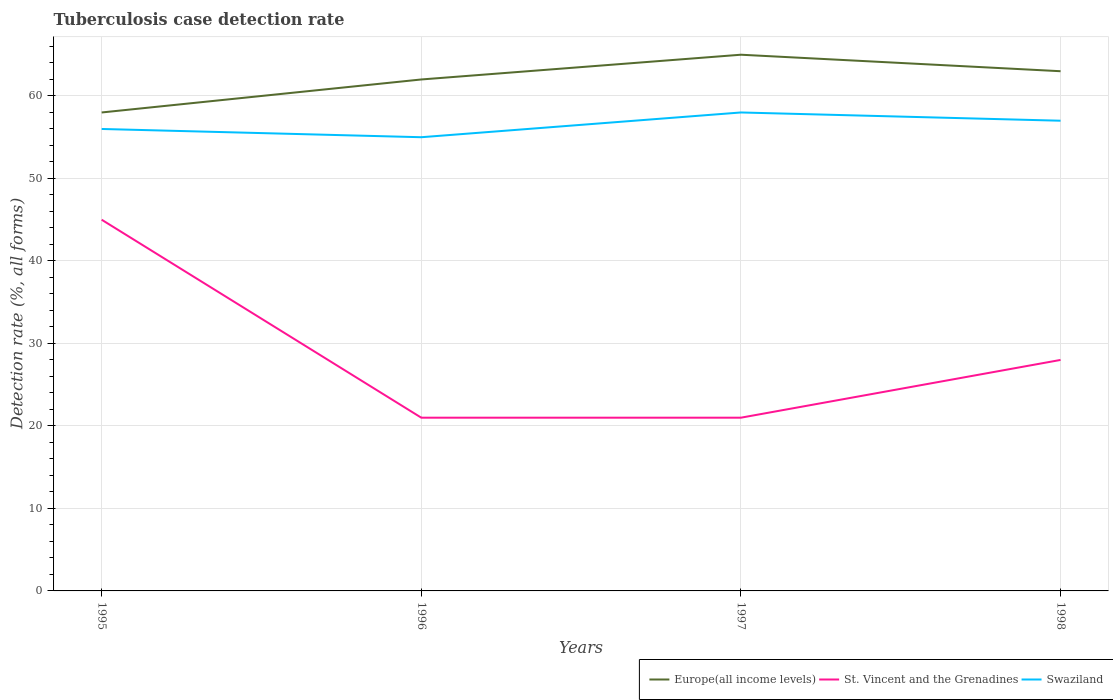Across all years, what is the maximum tuberculosis case detection rate in in St. Vincent and the Grenadines?
Provide a succinct answer. 21. What is the total tuberculosis case detection rate in in Europe(all income levels) in the graph?
Give a very brief answer. -7. What is the difference between the highest and the second highest tuberculosis case detection rate in in Europe(all income levels)?
Provide a short and direct response. 7. What is the difference between the highest and the lowest tuberculosis case detection rate in in Swaziland?
Give a very brief answer. 2. What is the difference between two consecutive major ticks on the Y-axis?
Ensure brevity in your answer.  10. Are the values on the major ticks of Y-axis written in scientific E-notation?
Ensure brevity in your answer.  No. What is the title of the graph?
Ensure brevity in your answer.  Tuberculosis case detection rate. What is the label or title of the Y-axis?
Give a very brief answer. Detection rate (%, all forms). What is the Detection rate (%, all forms) in Europe(all income levels) in 1995?
Offer a very short reply. 58. What is the Detection rate (%, all forms) in Swaziland in 1995?
Your response must be concise. 56. What is the Detection rate (%, all forms) in Europe(all income levels) in 1996?
Offer a terse response. 62. What is the Detection rate (%, all forms) in Swaziland in 1996?
Your response must be concise. 55. What is the Detection rate (%, all forms) in St. Vincent and the Grenadines in 1997?
Provide a short and direct response. 21. What is the Detection rate (%, all forms) of Europe(all income levels) in 1998?
Provide a succinct answer. 63. What is the Detection rate (%, all forms) of Swaziland in 1998?
Provide a short and direct response. 57. Across all years, what is the maximum Detection rate (%, all forms) of St. Vincent and the Grenadines?
Keep it short and to the point. 45. Across all years, what is the minimum Detection rate (%, all forms) in Europe(all income levels)?
Your response must be concise. 58. Across all years, what is the minimum Detection rate (%, all forms) of St. Vincent and the Grenadines?
Provide a succinct answer. 21. What is the total Detection rate (%, all forms) of Europe(all income levels) in the graph?
Your response must be concise. 248. What is the total Detection rate (%, all forms) of St. Vincent and the Grenadines in the graph?
Provide a succinct answer. 115. What is the total Detection rate (%, all forms) of Swaziland in the graph?
Offer a very short reply. 226. What is the difference between the Detection rate (%, all forms) of Europe(all income levels) in 1995 and that in 1996?
Keep it short and to the point. -4. What is the difference between the Detection rate (%, all forms) in Swaziland in 1995 and that in 1996?
Offer a terse response. 1. What is the difference between the Detection rate (%, all forms) in Europe(all income levels) in 1995 and that in 1997?
Provide a short and direct response. -7. What is the difference between the Detection rate (%, all forms) in St. Vincent and the Grenadines in 1995 and that in 1997?
Make the answer very short. 24. What is the difference between the Detection rate (%, all forms) of Swaziland in 1995 and that in 1997?
Provide a succinct answer. -2. What is the difference between the Detection rate (%, all forms) in Europe(all income levels) in 1995 and that in 1998?
Your answer should be very brief. -5. What is the difference between the Detection rate (%, all forms) in Europe(all income levels) in 1996 and that in 1997?
Your response must be concise. -3. What is the difference between the Detection rate (%, all forms) in St. Vincent and the Grenadines in 1996 and that in 1997?
Give a very brief answer. 0. What is the difference between the Detection rate (%, all forms) in Europe(all income levels) in 1996 and that in 1998?
Make the answer very short. -1. What is the difference between the Detection rate (%, all forms) of St. Vincent and the Grenadines in 1996 and that in 1998?
Make the answer very short. -7. What is the difference between the Detection rate (%, all forms) in Swaziland in 1996 and that in 1998?
Your answer should be compact. -2. What is the difference between the Detection rate (%, all forms) of Europe(all income levels) in 1997 and that in 1998?
Offer a very short reply. 2. What is the difference between the Detection rate (%, all forms) in St. Vincent and the Grenadines in 1997 and that in 1998?
Provide a short and direct response. -7. What is the difference between the Detection rate (%, all forms) in Swaziland in 1997 and that in 1998?
Your answer should be compact. 1. What is the difference between the Detection rate (%, all forms) of St. Vincent and the Grenadines in 1995 and the Detection rate (%, all forms) of Swaziland in 1996?
Your answer should be very brief. -10. What is the difference between the Detection rate (%, all forms) in Europe(all income levels) in 1995 and the Detection rate (%, all forms) in St. Vincent and the Grenadines in 1997?
Offer a terse response. 37. What is the difference between the Detection rate (%, all forms) in St. Vincent and the Grenadines in 1995 and the Detection rate (%, all forms) in Swaziland in 1997?
Offer a very short reply. -13. What is the difference between the Detection rate (%, all forms) in Europe(all income levels) in 1995 and the Detection rate (%, all forms) in St. Vincent and the Grenadines in 1998?
Keep it short and to the point. 30. What is the difference between the Detection rate (%, all forms) of Europe(all income levels) in 1996 and the Detection rate (%, all forms) of St. Vincent and the Grenadines in 1997?
Keep it short and to the point. 41. What is the difference between the Detection rate (%, all forms) in St. Vincent and the Grenadines in 1996 and the Detection rate (%, all forms) in Swaziland in 1997?
Give a very brief answer. -37. What is the difference between the Detection rate (%, all forms) in St. Vincent and the Grenadines in 1996 and the Detection rate (%, all forms) in Swaziland in 1998?
Provide a succinct answer. -36. What is the difference between the Detection rate (%, all forms) in Europe(all income levels) in 1997 and the Detection rate (%, all forms) in St. Vincent and the Grenadines in 1998?
Your response must be concise. 37. What is the difference between the Detection rate (%, all forms) of St. Vincent and the Grenadines in 1997 and the Detection rate (%, all forms) of Swaziland in 1998?
Provide a short and direct response. -36. What is the average Detection rate (%, all forms) in Europe(all income levels) per year?
Make the answer very short. 62. What is the average Detection rate (%, all forms) of St. Vincent and the Grenadines per year?
Provide a succinct answer. 28.75. What is the average Detection rate (%, all forms) in Swaziland per year?
Your answer should be very brief. 56.5. In the year 1995, what is the difference between the Detection rate (%, all forms) in St. Vincent and the Grenadines and Detection rate (%, all forms) in Swaziland?
Your answer should be compact. -11. In the year 1996, what is the difference between the Detection rate (%, all forms) in Europe(all income levels) and Detection rate (%, all forms) in St. Vincent and the Grenadines?
Offer a terse response. 41. In the year 1996, what is the difference between the Detection rate (%, all forms) in Europe(all income levels) and Detection rate (%, all forms) in Swaziland?
Provide a short and direct response. 7. In the year 1996, what is the difference between the Detection rate (%, all forms) in St. Vincent and the Grenadines and Detection rate (%, all forms) in Swaziland?
Give a very brief answer. -34. In the year 1997, what is the difference between the Detection rate (%, all forms) of Europe(all income levels) and Detection rate (%, all forms) of St. Vincent and the Grenadines?
Provide a short and direct response. 44. In the year 1997, what is the difference between the Detection rate (%, all forms) in St. Vincent and the Grenadines and Detection rate (%, all forms) in Swaziland?
Provide a short and direct response. -37. In the year 1998, what is the difference between the Detection rate (%, all forms) of Europe(all income levels) and Detection rate (%, all forms) of St. Vincent and the Grenadines?
Provide a short and direct response. 35. In the year 1998, what is the difference between the Detection rate (%, all forms) in Europe(all income levels) and Detection rate (%, all forms) in Swaziland?
Ensure brevity in your answer.  6. What is the ratio of the Detection rate (%, all forms) in Europe(all income levels) in 1995 to that in 1996?
Your response must be concise. 0.94. What is the ratio of the Detection rate (%, all forms) of St. Vincent and the Grenadines in 1995 to that in 1996?
Your response must be concise. 2.14. What is the ratio of the Detection rate (%, all forms) of Swaziland in 1995 to that in 1996?
Give a very brief answer. 1.02. What is the ratio of the Detection rate (%, all forms) of Europe(all income levels) in 1995 to that in 1997?
Your answer should be very brief. 0.89. What is the ratio of the Detection rate (%, all forms) of St. Vincent and the Grenadines in 1995 to that in 1997?
Ensure brevity in your answer.  2.14. What is the ratio of the Detection rate (%, all forms) of Swaziland in 1995 to that in 1997?
Ensure brevity in your answer.  0.97. What is the ratio of the Detection rate (%, all forms) of Europe(all income levels) in 1995 to that in 1998?
Your answer should be very brief. 0.92. What is the ratio of the Detection rate (%, all forms) of St. Vincent and the Grenadines in 1995 to that in 1998?
Offer a very short reply. 1.61. What is the ratio of the Detection rate (%, all forms) of Swaziland in 1995 to that in 1998?
Your answer should be very brief. 0.98. What is the ratio of the Detection rate (%, all forms) in Europe(all income levels) in 1996 to that in 1997?
Your response must be concise. 0.95. What is the ratio of the Detection rate (%, all forms) of St. Vincent and the Grenadines in 1996 to that in 1997?
Offer a very short reply. 1. What is the ratio of the Detection rate (%, all forms) of Swaziland in 1996 to that in 1997?
Your answer should be compact. 0.95. What is the ratio of the Detection rate (%, all forms) in Europe(all income levels) in 1996 to that in 1998?
Offer a terse response. 0.98. What is the ratio of the Detection rate (%, all forms) in St. Vincent and the Grenadines in 1996 to that in 1998?
Your answer should be compact. 0.75. What is the ratio of the Detection rate (%, all forms) of Swaziland in 1996 to that in 1998?
Your answer should be very brief. 0.96. What is the ratio of the Detection rate (%, all forms) of Europe(all income levels) in 1997 to that in 1998?
Make the answer very short. 1.03. What is the ratio of the Detection rate (%, all forms) of Swaziland in 1997 to that in 1998?
Ensure brevity in your answer.  1.02. What is the difference between the highest and the second highest Detection rate (%, all forms) in Europe(all income levels)?
Provide a succinct answer. 2. What is the difference between the highest and the second highest Detection rate (%, all forms) in Swaziland?
Offer a very short reply. 1. What is the difference between the highest and the lowest Detection rate (%, all forms) of Europe(all income levels)?
Keep it short and to the point. 7. What is the difference between the highest and the lowest Detection rate (%, all forms) in St. Vincent and the Grenadines?
Provide a succinct answer. 24. What is the difference between the highest and the lowest Detection rate (%, all forms) of Swaziland?
Provide a short and direct response. 3. 